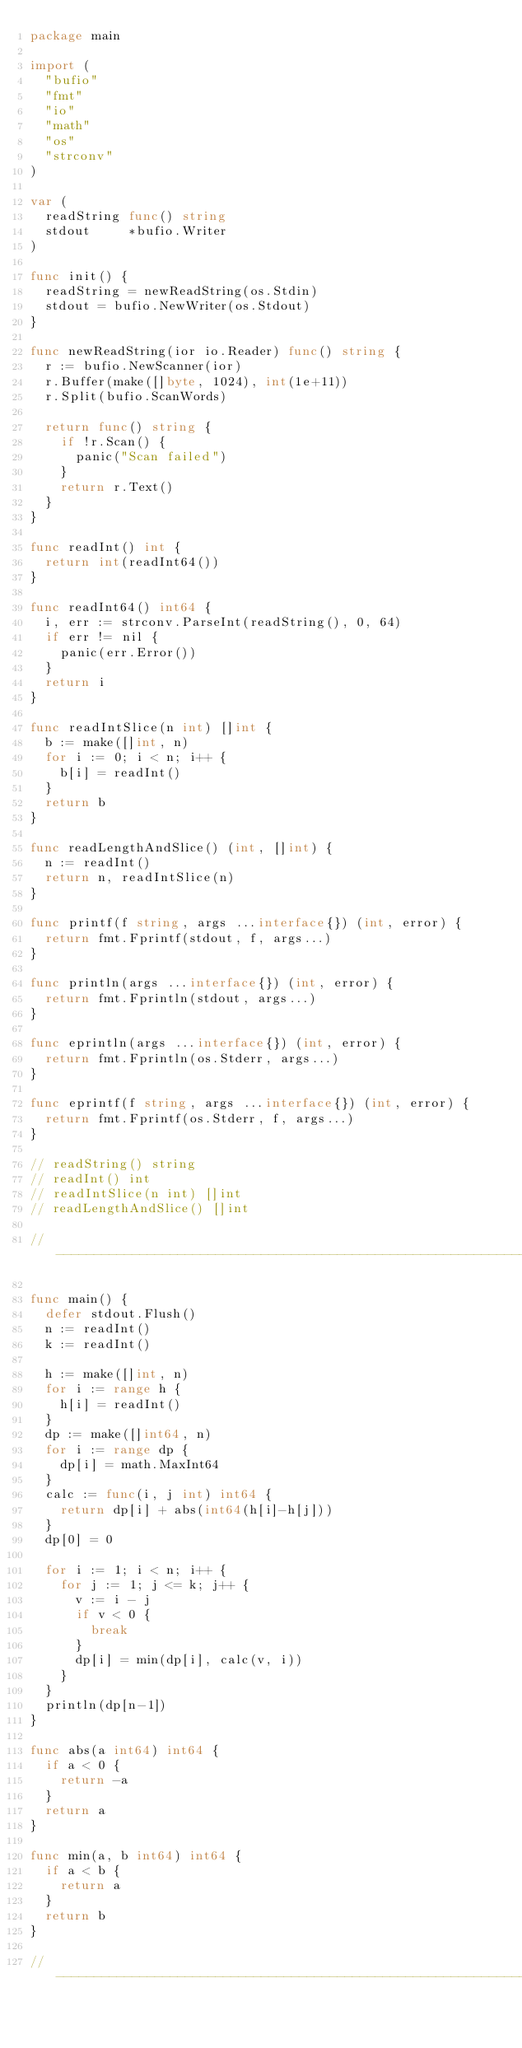<code> <loc_0><loc_0><loc_500><loc_500><_Go_>package main

import (
	"bufio"
	"fmt"
	"io"
	"math"
	"os"
	"strconv"
)

var (
	readString func() string
	stdout     *bufio.Writer
)

func init() {
	readString = newReadString(os.Stdin)
	stdout = bufio.NewWriter(os.Stdout)
}

func newReadString(ior io.Reader) func() string {
	r := bufio.NewScanner(ior)
	r.Buffer(make([]byte, 1024), int(1e+11))
	r.Split(bufio.ScanWords)

	return func() string {
		if !r.Scan() {
			panic("Scan failed")
		}
		return r.Text()
	}
}

func readInt() int {
	return int(readInt64())
}

func readInt64() int64 {
	i, err := strconv.ParseInt(readString(), 0, 64)
	if err != nil {
		panic(err.Error())
	}
	return i
}

func readIntSlice(n int) []int {
	b := make([]int, n)
	for i := 0; i < n; i++ {
		b[i] = readInt()
	}
	return b
}

func readLengthAndSlice() (int, []int) {
	n := readInt()
	return n, readIntSlice(n)
}

func printf(f string, args ...interface{}) (int, error) {
	return fmt.Fprintf(stdout, f, args...)
}

func println(args ...interface{}) (int, error) {
	return fmt.Fprintln(stdout, args...)
}

func eprintln(args ...interface{}) (int, error) {
	return fmt.Fprintln(os.Stderr, args...)
}

func eprintf(f string, args ...interface{}) (int, error) {
	return fmt.Fprintf(os.Stderr, f, args...)
}

// readString() string
// readInt() int
// readIntSlice(n int) []int
// readLengthAndSlice() []int

// -----------------------------------------------------------------------------

func main() {
	defer stdout.Flush()
	n := readInt()
	k := readInt()

	h := make([]int, n)
	for i := range h {
		h[i] = readInt()
	}
	dp := make([]int64, n)
	for i := range dp {
		dp[i] = math.MaxInt64
	}
	calc := func(i, j int) int64 {
		return dp[i] + abs(int64(h[i]-h[j]))
	}
	dp[0] = 0

	for i := 1; i < n; i++ {
		for j := 1; j <= k; j++ {
			v := i - j
			if v < 0 {
				break
			}
			dp[i] = min(dp[i], calc(v, i))
		}
	}
	println(dp[n-1])
}

func abs(a int64) int64 {
	if a < 0 {
		return -a
	}
	return a
}

func min(a, b int64) int64 {
	if a < b {
		return a
	}
	return b
}

// -----------------------------------------------------------------------------
</code> 